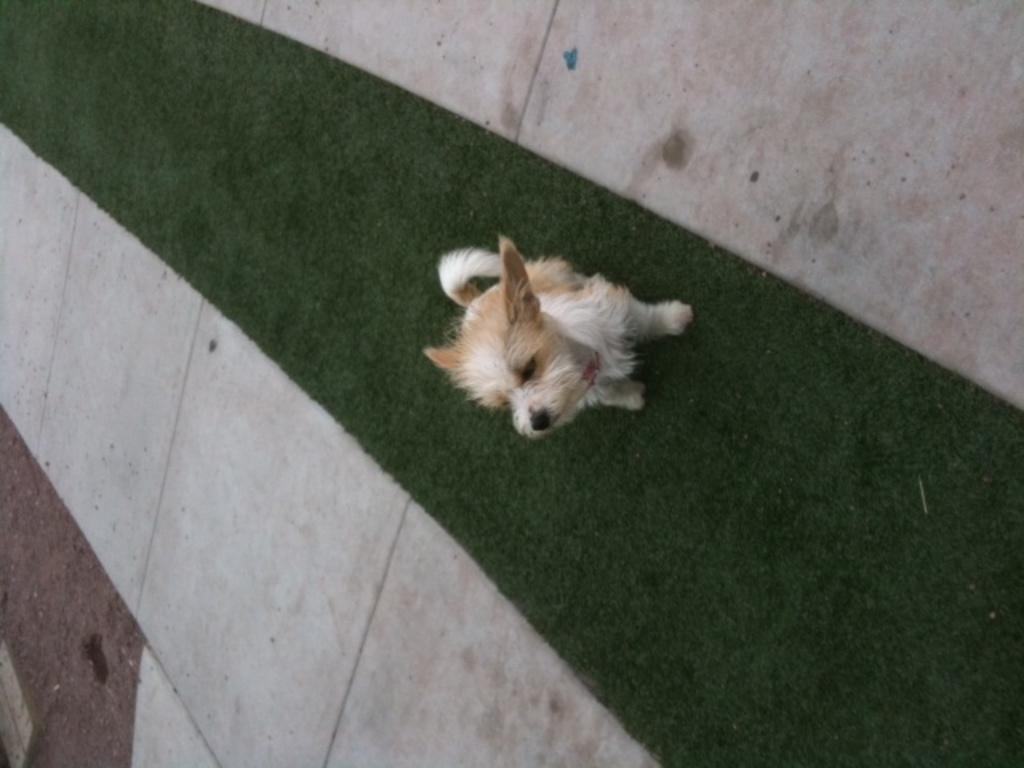What animal is present in the image? There is a dog in the image. What is the dog doing in the image? The dog is sitting on a mat. What type of flooring is visible in the image? There are white tiles on either side of the mat. What type of shoes is the stranger wearing in the image? There is no stranger present in the image, so it is not possible to determine what type of shoes they might be wearing. 